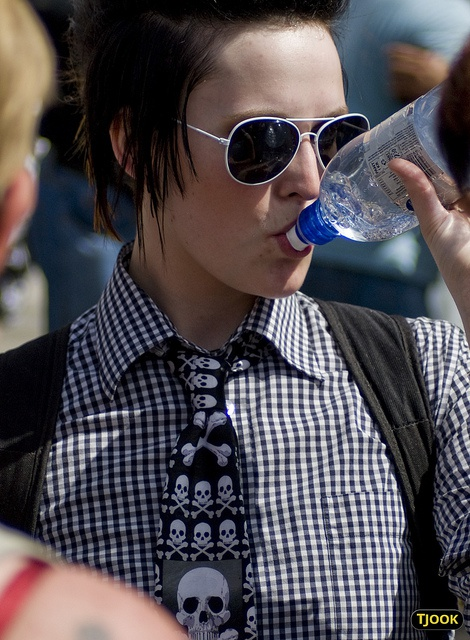Describe the objects in this image and their specific colors. I can see people in black, tan, gray, darkgray, and navy tones, backpack in tan, black, and gray tones, tie in tan, black, and gray tones, people in gray and tan tones, and people in tan, black, blue, gray, and darkgray tones in this image. 